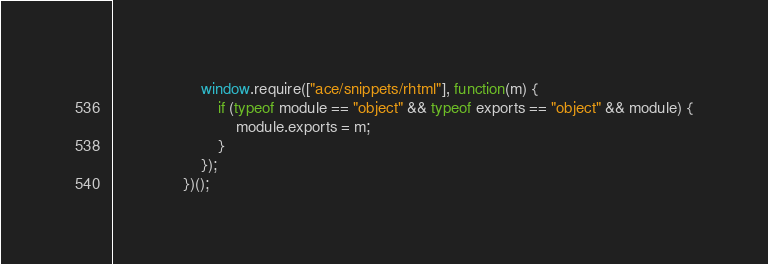Convert code to text. <code><loc_0><loc_0><loc_500><loc_500><_JavaScript_>                    window.require(["ace/snippets/rhtml"], function(m) {
                        if (typeof module == "object" && typeof exports == "object" && module) {
                            module.exports = m;
                        }
                    });
                })();</code> 